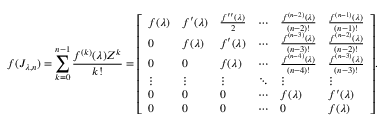Convert formula to latex. <formula><loc_0><loc_0><loc_500><loc_500>f ( J _ { \lambda , n } ) = \sum _ { k = 0 } ^ { n - 1 } { \frac { f ^ { ( k ) } ( \lambda ) Z ^ { k } } { k ! } } = { \left [ \begin{array} { l l l l l l } { f ( \lambda ) } & { f ^ { \prime } ( \lambda ) } & { { \frac { f ^ { \prime \prime } ( \lambda ) } { 2 } } } & { \cdots } & { { \frac { f ^ { ( n - 2 ) } ( \lambda ) } { ( n - 2 ) ! } } } & { { \frac { f ^ { ( n - 1 ) } ( \lambda ) } { ( n - 1 ) ! } } } \\ { 0 } & { f ( \lambda ) } & { f ^ { \prime } ( \lambda ) } & { \cdots } & { { \frac { f ^ { ( n - 3 ) } ( \lambda ) } { ( n - 3 ) ! } } } & { { \frac { f ^ { ( n - 2 ) } ( \lambda ) } { ( n - 2 ) ! } } } \\ { 0 } & { 0 } & { f ( \lambda ) } & { \cdots } & { { \frac { f ^ { ( n - 4 ) } ( \lambda ) } { ( n - 4 ) ! } } } & { { \frac { f ^ { ( n - 3 ) } ( \lambda ) } { ( n - 3 ) ! } } } \\ { \vdots } & { \vdots } & { \vdots } & { \ddots } & { \vdots } & { \vdots } \\ { 0 } & { 0 } & { 0 } & { \cdots } & { f ( \lambda ) } & { f ^ { \prime } ( \lambda ) } \\ { 0 } & { 0 } & { 0 } & { \cdots } & { 0 } & { f ( \lambda ) } \end{array} \right ] } .</formula> 